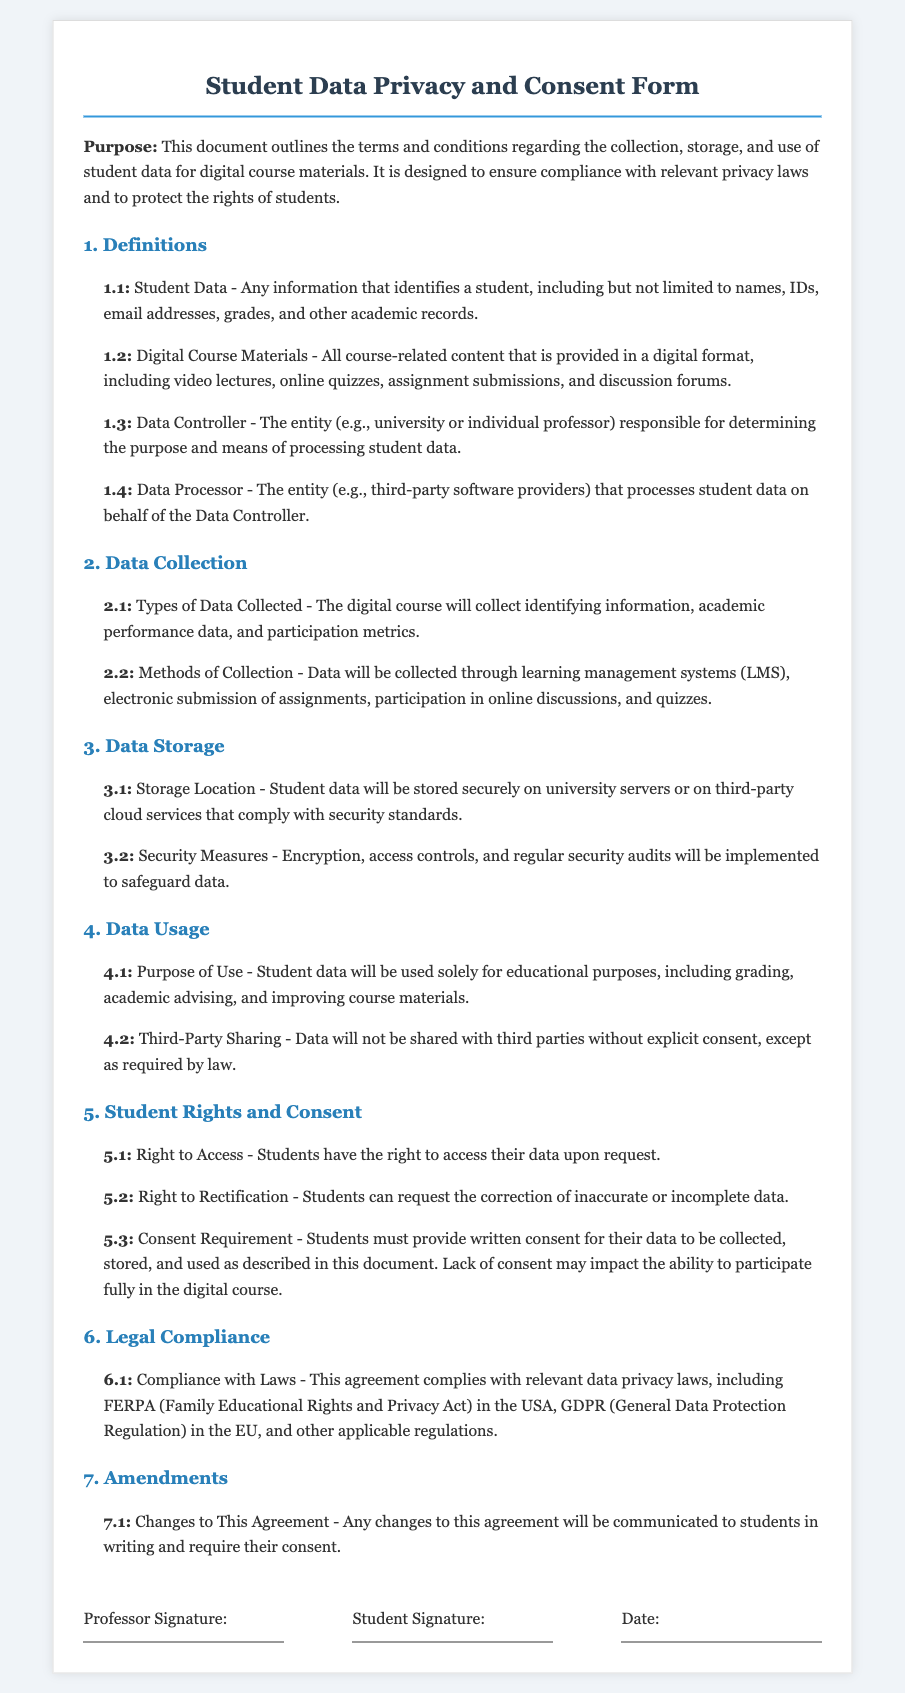What is the purpose of this document? The document outlines the terms and conditions regarding the collection, storage, and use of student data for digital course materials.
Answer: This document outlines the terms and conditions regarding the collection, storage, and use of student data for digital course materials What types of data will be collected? The types of data collected are specified in section 2.1, which states that identifying information, academic performance data, and participation metrics will be collected.
Answer: Identifying information, academic performance data, and participation metrics Which laws does this agreement comply with? The document mentions compliance with relevant data privacy laws, specifically FERPA and GDPR, indicating legal adherence.
Answer: FERPA and GDPR What is required from students regarding their data? The document indicates that students must provide written consent for their data to be collected, stored, and used as described.
Answer: Written consent What security measures are mentioned for data storage? Section 3.2 specifies that encryption, access controls, and regular security audits will be implemented to safeguard data.
Answer: Encryption, access controls, and regular security audits What rights do students have regarding their data? Section 5 outlines various rights, including the right to access and the right to rectification, highlighting the students' rights over their data.
Answer: Right to access and right to rectification What happens if a student doesn't provide consent? The document states that lack of consent may impact the ability to participate fully in the digital course.
Answer: Impact ability to participate fully How will changes to the agreement be communicated? Section 7.1 describes that any changes will be communicated to students in writing and require their consent.
Answer: In writing and require their consent 